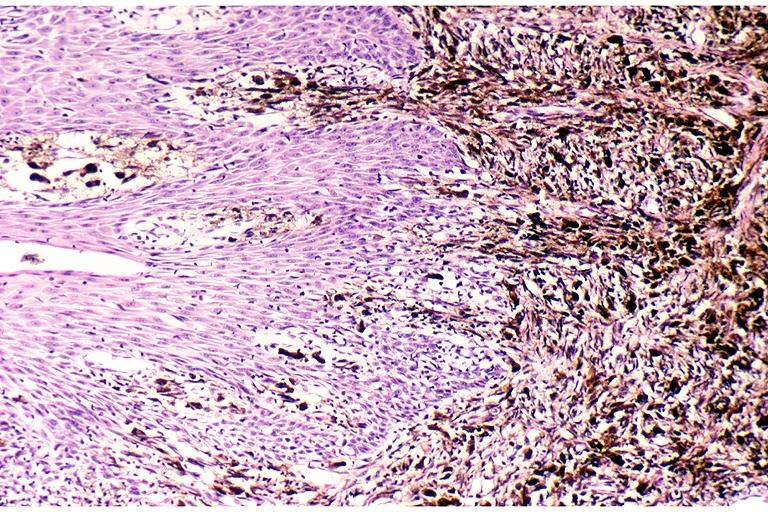does close-up show melanoma?
Answer the question using a single word or phrase. No 